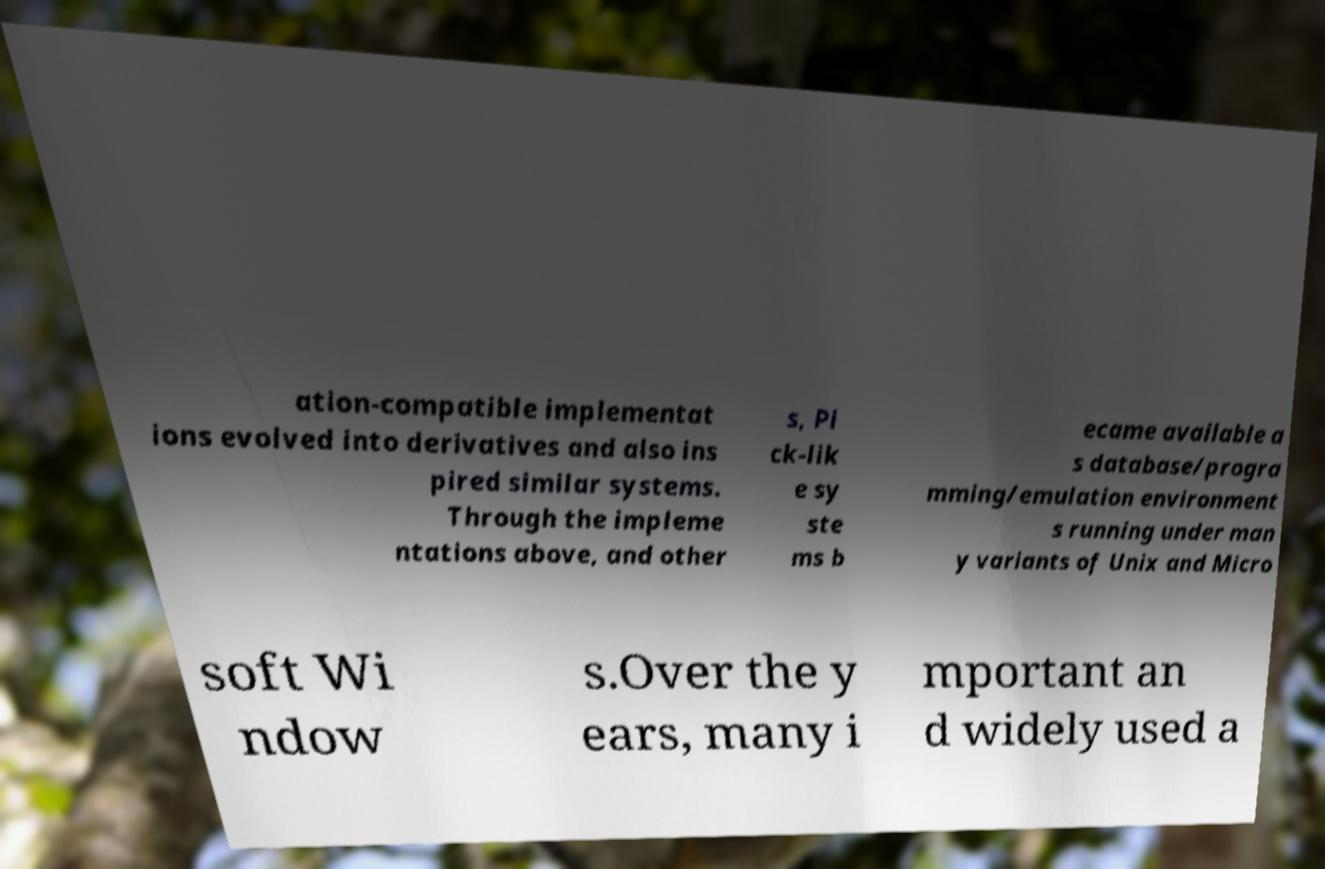Could you assist in decoding the text presented in this image and type it out clearly? ation-compatible implementat ions evolved into derivatives and also ins pired similar systems. Through the impleme ntations above, and other s, Pi ck-lik e sy ste ms b ecame available a s database/progra mming/emulation environment s running under man y variants of Unix and Micro soft Wi ndow s.Over the y ears, many i mportant an d widely used a 